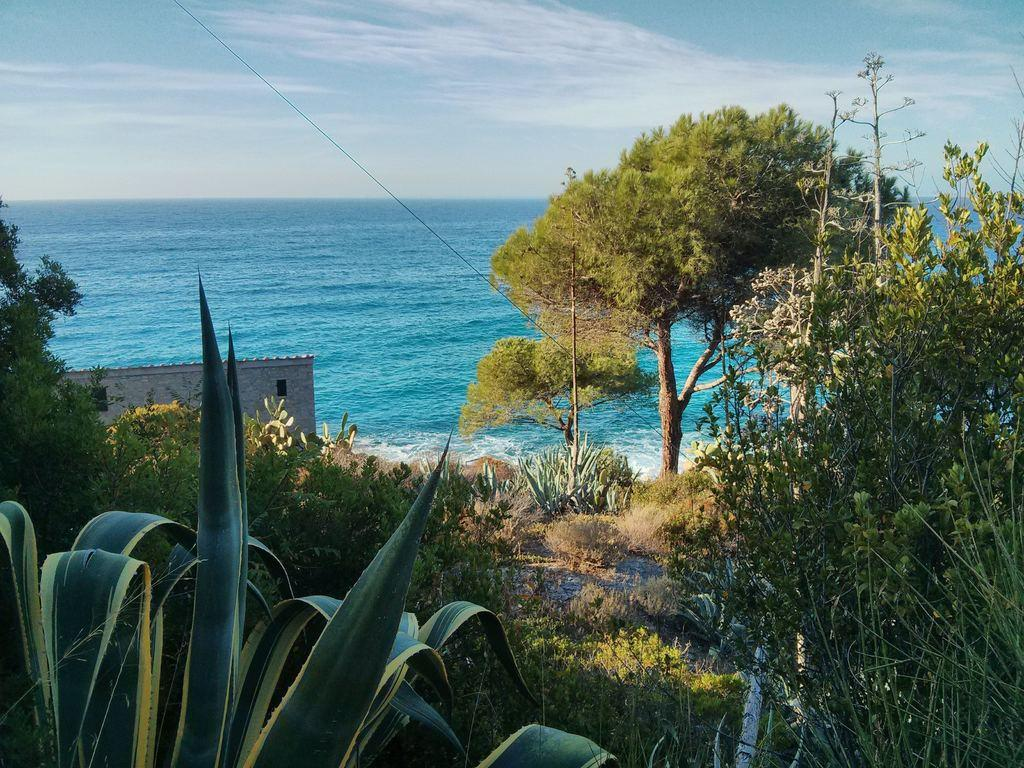What type of vegetation can be seen in the image? There are plants, grass, and trees visible in the image. What type of structure is present in the image? There is a building in the image. What else can be seen in the image besides the vegetation and the building? There is a wire and water visible in the background of the image. What is visible at the top of the image? The sky is visible at the top of the image. How many mittens are hanging on the wire in the image? There are no mittens present in the image; it features plants, grass, trees, a building, a wire, water, and the sky. What type of debt is being discussed in the image? There is no mention of debt in the image; it focuses on the natural and man-made elements present. 